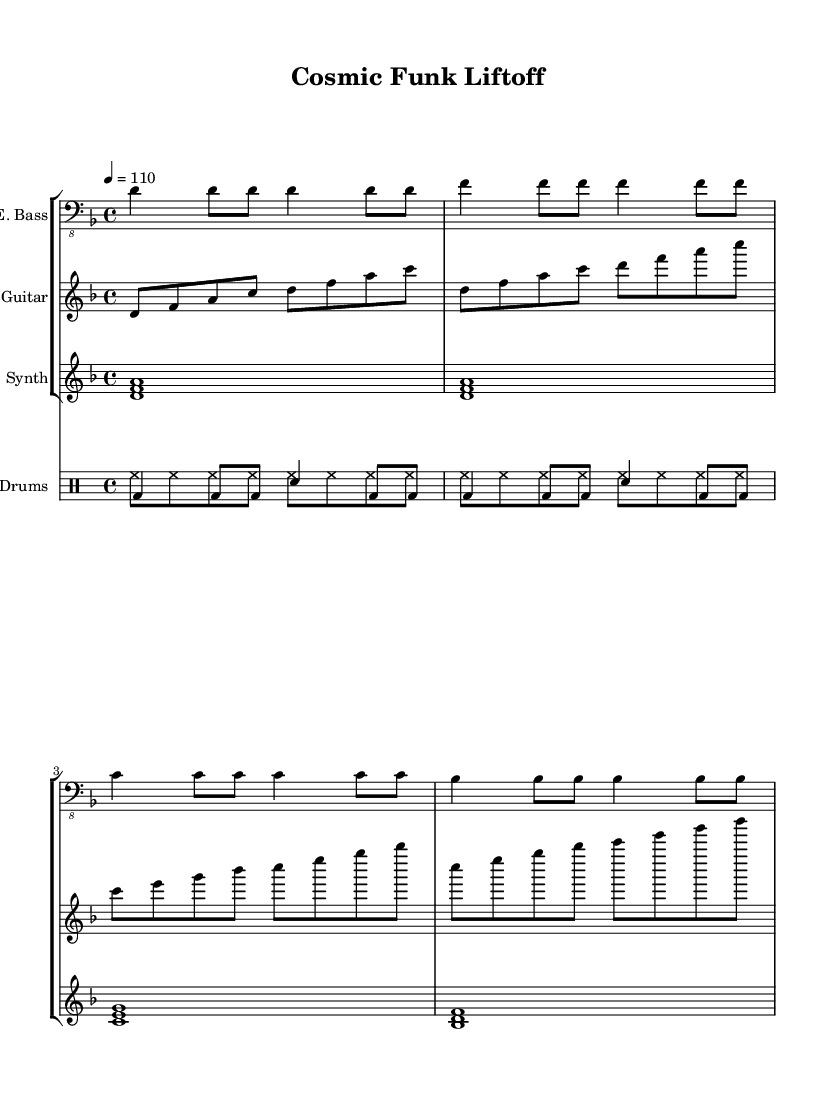What is the key signature of this music? The key signature is D minor, which includes one flat (B flat).
Answer: D minor What is the time signature of this music? The time signature shows 4 beats per measure, indicated by the 4/4 notation.
Answer: 4/4 What is the tempo marking for this piece? The tempo marking indicates a speed of 110 beats per minute, shown as "4 = 110".
Answer: 110 How many measures are in the electric bass part? The electric bass part has 8 measures, as counted from the notation provided in the score.
Answer: 8 Which instrument plays the first chord? The synthesizer plays the first chord, represented by the notated harmony of D, F, and A.
Answer: Synthesizer How does the drum pattern incorporate a funk style? The drum pattern is characterized by syncopation and off-beats, typical of funk, demonstrated through the combination of bass drum and snare hits.
Answer: Syncopation What is the play style recommended for the electric guitar in funk? The electric guitar is typically played with a rhythmic strumming style to enhance the groove, as illustrated by the repeated eighth notes in the notation.
Answer: Rhythmic strumming 